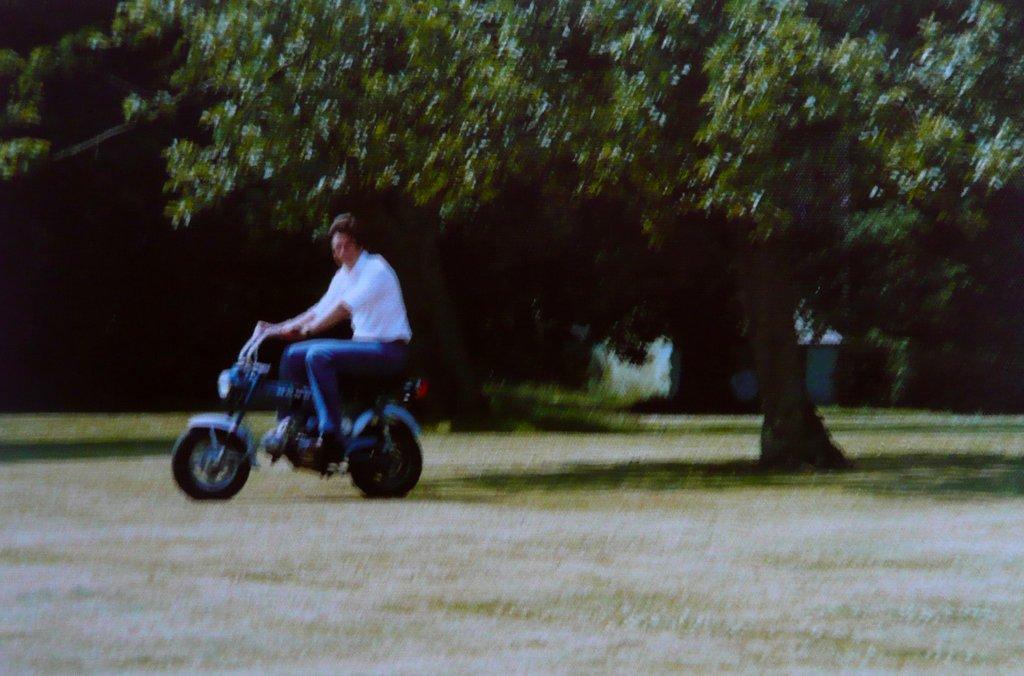Can you describe this image briefly? This man wore white shirt and riding his motorbike. Far there are trees and plants. 